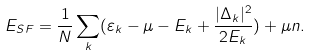Convert formula to latex. <formula><loc_0><loc_0><loc_500><loc_500>E _ { S F } = \frac { 1 } { N } \sum _ { k } ( \varepsilon _ { k } - \mu - E _ { k } + \frac { | \Delta _ { k } | ^ { 2 } } { 2 E _ { k } } ) + \mu n .</formula> 